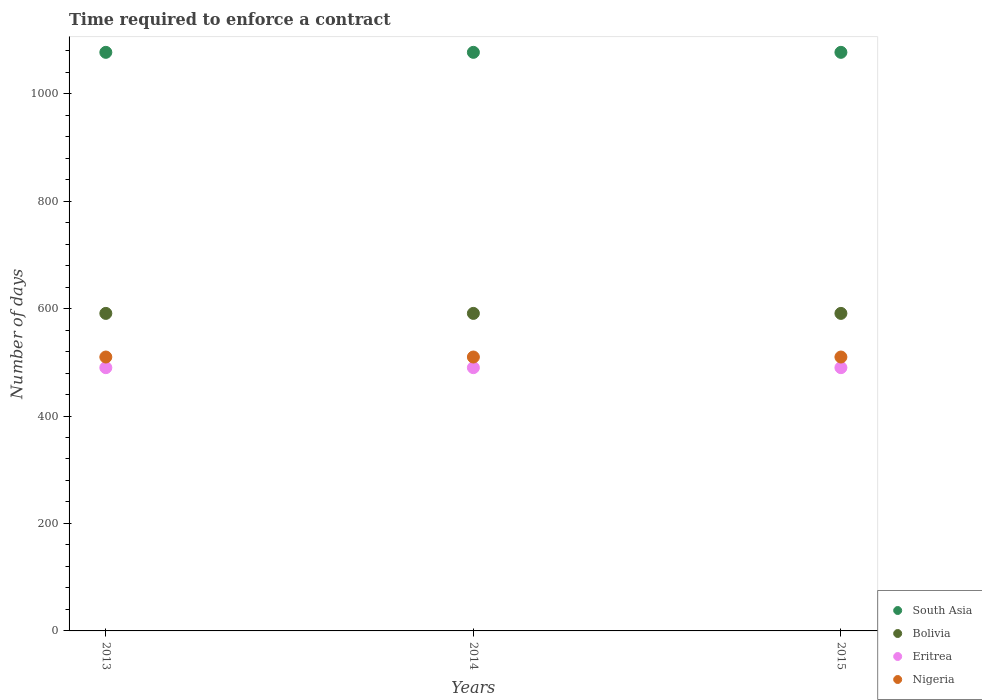Is the number of dotlines equal to the number of legend labels?
Keep it short and to the point. Yes. What is the number of days required to enforce a contract in South Asia in 2014?
Give a very brief answer. 1076.9. Across all years, what is the maximum number of days required to enforce a contract in Bolivia?
Provide a succinct answer. 591. Across all years, what is the minimum number of days required to enforce a contract in Nigeria?
Make the answer very short. 509.8. In which year was the number of days required to enforce a contract in Eritrea minimum?
Provide a short and direct response. 2013. What is the total number of days required to enforce a contract in Bolivia in the graph?
Keep it short and to the point. 1773. What is the difference between the number of days required to enforce a contract in South Asia in 2015 and the number of days required to enforce a contract in Nigeria in 2014?
Your response must be concise. 567.1. What is the average number of days required to enforce a contract in South Asia per year?
Give a very brief answer. 1076.9. In the year 2014, what is the difference between the number of days required to enforce a contract in Eritrea and number of days required to enforce a contract in Nigeria?
Offer a very short reply. -19.8. What is the ratio of the number of days required to enforce a contract in Nigeria in 2013 to that in 2014?
Provide a succinct answer. 1. Is the number of days required to enforce a contract in Eritrea in 2013 less than that in 2014?
Give a very brief answer. No. What is the difference between the highest and the lowest number of days required to enforce a contract in South Asia?
Keep it short and to the point. 0. In how many years, is the number of days required to enforce a contract in South Asia greater than the average number of days required to enforce a contract in South Asia taken over all years?
Offer a very short reply. 0. Is the sum of the number of days required to enforce a contract in Eritrea in 2013 and 2015 greater than the maximum number of days required to enforce a contract in Nigeria across all years?
Your answer should be compact. Yes. Is it the case that in every year, the sum of the number of days required to enforce a contract in Eritrea and number of days required to enforce a contract in Bolivia  is greater than the sum of number of days required to enforce a contract in Nigeria and number of days required to enforce a contract in South Asia?
Make the answer very short. Yes. Is it the case that in every year, the sum of the number of days required to enforce a contract in South Asia and number of days required to enforce a contract in Bolivia  is greater than the number of days required to enforce a contract in Nigeria?
Your response must be concise. Yes. Does the number of days required to enforce a contract in South Asia monotonically increase over the years?
Offer a very short reply. No. Is the number of days required to enforce a contract in Nigeria strictly greater than the number of days required to enforce a contract in Eritrea over the years?
Give a very brief answer. Yes. How many dotlines are there?
Provide a succinct answer. 4. How many years are there in the graph?
Your answer should be very brief. 3. What is the difference between two consecutive major ticks on the Y-axis?
Give a very brief answer. 200. Are the values on the major ticks of Y-axis written in scientific E-notation?
Provide a short and direct response. No. Does the graph contain any zero values?
Your answer should be compact. No. How many legend labels are there?
Your answer should be compact. 4. How are the legend labels stacked?
Provide a short and direct response. Vertical. What is the title of the graph?
Your answer should be very brief. Time required to enforce a contract. Does "Pakistan" appear as one of the legend labels in the graph?
Ensure brevity in your answer.  No. What is the label or title of the X-axis?
Ensure brevity in your answer.  Years. What is the label or title of the Y-axis?
Make the answer very short. Number of days. What is the Number of days in South Asia in 2013?
Your answer should be compact. 1076.9. What is the Number of days of Bolivia in 2013?
Your answer should be compact. 591. What is the Number of days of Eritrea in 2013?
Provide a short and direct response. 490. What is the Number of days in Nigeria in 2013?
Offer a very short reply. 509.8. What is the Number of days in South Asia in 2014?
Ensure brevity in your answer.  1076.9. What is the Number of days of Bolivia in 2014?
Give a very brief answer. 591. What is the Number of days in Eritrea in 2014?
Provide a short and direct response. 490. What is the Number of days in Nigeria in 2014?
Your response must be concise. 509.8. What is the Number of days in South Asia in 2015?
Give a very brief answer. 1076.9. What is the Number of days of Bolivia in 2015?
Your answer should be very brief. 591. What is the Number of days of Eritrea in 2015?
Ensure brevity in your answer.  490. What is the Number of days in Nigeria in 2015?
Offer a terse response. 509.8. Across all years, what is the maximum Number of days of South Asia?
Ensure brevity in your answer.  1076.9. Across all years, what is the maximum Number of days in Bolivia?
Provide a succinct answer. 591. Across all years, what is the maximum Number of days in Eritrea?
Your answer should be very brief. 490. Across all years, what is the maximum Number of days in Nigeria?
Offer a terse response. 509.8. Across all years, what is the minimum Number of days in South Asia?
Provide a succinct answer. 1076.9. Across all years, what is the minimum Number of days of Bolivia?
Your answer should be compact. 591. Across all years, what is the minimum Number of days in Eritrea?
Your answer should be very brief. 490. Across all years, what is the minimum Number of days in Nigeria?
Offer a terse response. 509.8. What is the total Number of days of South Asia in the graph?
Ensure brevity in your answer.  3230.7. What is the total Number of days of Bolivia in the graph?
Make the answer very short. 1773. What is the total Number of days of Eritrea in the graph?
Your response must be concise. 1470. What is the total Number of days in Nigeria in the graph?
Give a very brief answer. 1529.4. What is the difference between the Number of days in Bolivia in 2013 and that in 2014?
Your answer should be compact. 0. What is the difference between the Number of days of Nigeria in 2013 and that in 2014?
Your answer should be very brief. 0. What is the difference between the Number of days of Nigeria in 2013 and that in 2015?
Your response must be concise. 0. What is the difference between the Number of days in Eritrea in 2014 and that in 2015?
Make the answer very short. 0. What is the difference between the Number of days of South Asia in 2013 and the Number of days of Bolivia in 2014?
Your answer should be very brief. 485.9. What is the difference between the Number of days in South Asia in 2013 and the Number of days in Eritrea in 2014?
Keep it short and to the point. 586.9. What is the difference between the Number of days in South Asia in 2013 and the Number of days in Nigeria in 2014?
Keep it short and to the point. 567.1. What is the difference between the Number of days in Bolivia in 2013 and the Number of days in Eritrea in 2014?
Your response must be concise. 101. What is the difference between the Number of days in Bolivia in 2013 and the Number of days in Nigeria in 2014?
Ensure brevity in your answer.  81.2. What is the difference between the Number of days of Eritrea in 2013 and the Number of days of Nigeria in 2014?
Provide a short and direct response. -19.8. What is the difference between the Number of days of South Asia in 2013 and the Number of days of Bolivia in 2015?
Keep it short and to the point. 485.9. What is the difference between the Number of days in South Asia in 2013 and the Number of days in Eritrea in 2015?
Offer a very short reply. 586.9. What is the difference between the Number of days of South Asia in 2013 and the Number of days of Nigeria in 2015?
Give a very brief answer. 567.1. What is the difference between the Number of days in Bolivia in 2013 and the Number of days in Eritrea in 2015?
Provide a short and direct response. 101. What is the difference between the Number of days in Bolivia in 2013 and the Number of days in Nigeria in 2015?
Offer a terse response. 81.2. What is the difference between the Number of days of Eritrea in 2013 and the Number of days of Nigeria in 2015?
Your answer should be very brief. -19.8. What is the difference between the Number of days in South Asia in 2014 and the Number of days in Bolivia in 2015?
Give a very brief answer. 485.9. What is the difference between the Number of days of South Asia in 2014 and the Number of days of Eritrea in 2015?
Your answer should be very brief. 586.9. What is the difference between the Number of days in South Asia in 2014 and the Number of days in Nigeria in 2015?
Offer a terse response. 567.1. What is the difference between the Number of days in Bolivia in 2014 and the Number of days in Eritrea in 2015?
Provide a succinct answer. 101. What is the difference between the Number of days of Bolivia in 2014 and the Number of days of Nigeria in 2015?
Keep it short and to the point. 81.2. What is the difference between the Number of days in Eritrea in 2014 and the Number of days in Nigeria in 2015?
Your answer should be very brief. -19.8. What is the average Number of days of South Asia per year?
Offer a very short reply. 1076.9. What is the average Number of days of Bolivia per year?
Your answer should be very brief. 591. What is the average Number of days in Eritrea per year?
Your response must be concise. 490. What is the average Number of days in Nigeria per year?
Offer a very short reply. 509.8. In the year 2013, what is the difference between the Number of days of South Asia and Number of days of Bolivia?
Provide a short and direct response. 485.9. In the year 2013, what is the difference between the Number of days in South Asia and Number of days in Eritrea?
Your answer should be very brief. 586.9. In the year 2013, what is the difference between the Number of days in South Asia and Number of days in Nigeria?
Offer a terse response. 567.1. In the year 2013, what is the difference between the Number of days in Bolivia and Number of days in Eritrea?
Offer a terse response. 101. In the year 2013, what is the difference between the Number of days in Bolivia and Number of days in Nigeria?
Give a very brief answer. 81.2. In the year 2013, what is the difference between the Number of days of Eritrea and Number of days of Nigeria?
Offer a very short reply. -19.8. In the year 2014, what is the difference between the Number of days of South Asia and Number of days of Bolivia?
Make the answer very short. 485.9. In the year 2014, what is the difference between the Number of days in South Asia and Number of days in Eritrea?
Your response must be concise. 586.9. In the year 2014, what is the difference between the Number of days of South Asia and Number of days of Nigeria?
Your answer should be compact. 567.1. In the year 2014, what is the difference between the Number of days of Bolivia and Number of days of Eritrea?
Give a very brief answer. 101. In the year 2014, what is the difference between the Number of days of Bolivia and Number of days of Nigeria?
Offer a terse response. 81.2. In the year 2014, what is the difference between the Number of days of Eritrea and Number of days of Nigeria?
Keep it short and to the point. -19.8. In the year 2015, what is the difference between the Number of days of South Asia and Number of days of Bolivia?
Your response must be concise. 485.9. In the year 2015, what is the difference between the Number of days of South Asia and Number of days of Eritrea?
Your answer should be very brief. 586.9. In the year 2015, what is the difference between the Number of days in South Asia and Number of days in Nigeria?
Your response must be concise. 567.1. In the year 2015, what is the difference between the Number of days of Bolivia and Number of days of Eritrea?
Offer a very short reply. 101. In the year 2015, what is the difference between the Number of days of Bolivia and Number of days of Nigeria?
Offer a terse response. 81.2. In the year 2015, what is the difference between the Number of days in Eritrea and Number of days in Nigeria?
Offer a terse response. -19.8. What is the ratio of the Number of days of Bolivia in 2013 to that in 2014?
Provide a short and direct response. 1. What is the ratio of the Number of days in Eritrea in 2013 to that in 2014?
Your response must be concise. 1. What is the ratio of the Number of days in Nigeria in 2013 to that in 2014?
Your answer should be very brief. 1. What is the ratio of the Number of days of South Asia in 2013 to that in 2015?
Make the answer very short. 1. What is the ratio of the Number of days of Bolivia in 2013 to that in 2015?
Give a very brief answer. 1. What is the ratio of the Number of days in Eritrea in 2013 to that in 2015?
Make the answer very short. 1. What is the ratio of the Number of days in South Asia in 2014 to that in 2015?
Provide a short and direct response. 1. What is the ratio of the Number of days in Bolivia in 2014 to that in 2015?
Provide a succinct answer. 1. What is the ratio of the Number of days of Eritrea in 2014 to that in 2015?
Your answer should be very brief. 1. What is the difference between the highest and the second highest Number of days of Bolivia?
Offer a very short reply. 0. What is the difference between the highest and the second highest Number of days of Eritrea?
Provide a short and direct response. 0. What is the difference between the highest and the second highest Number of days of Nigeria?
Your answer should be compact. 0. What is the difference between the highest and the lowest Number of days of South Asia?
Provide a short and direct response. 0. What is the difference between the highest and the lowest Number of days in Bolivia?
Provide a succinct answer. 0. What is the difference between the highest and the lowest Number of days in Nigeria?
Offer a terse response. 0. 